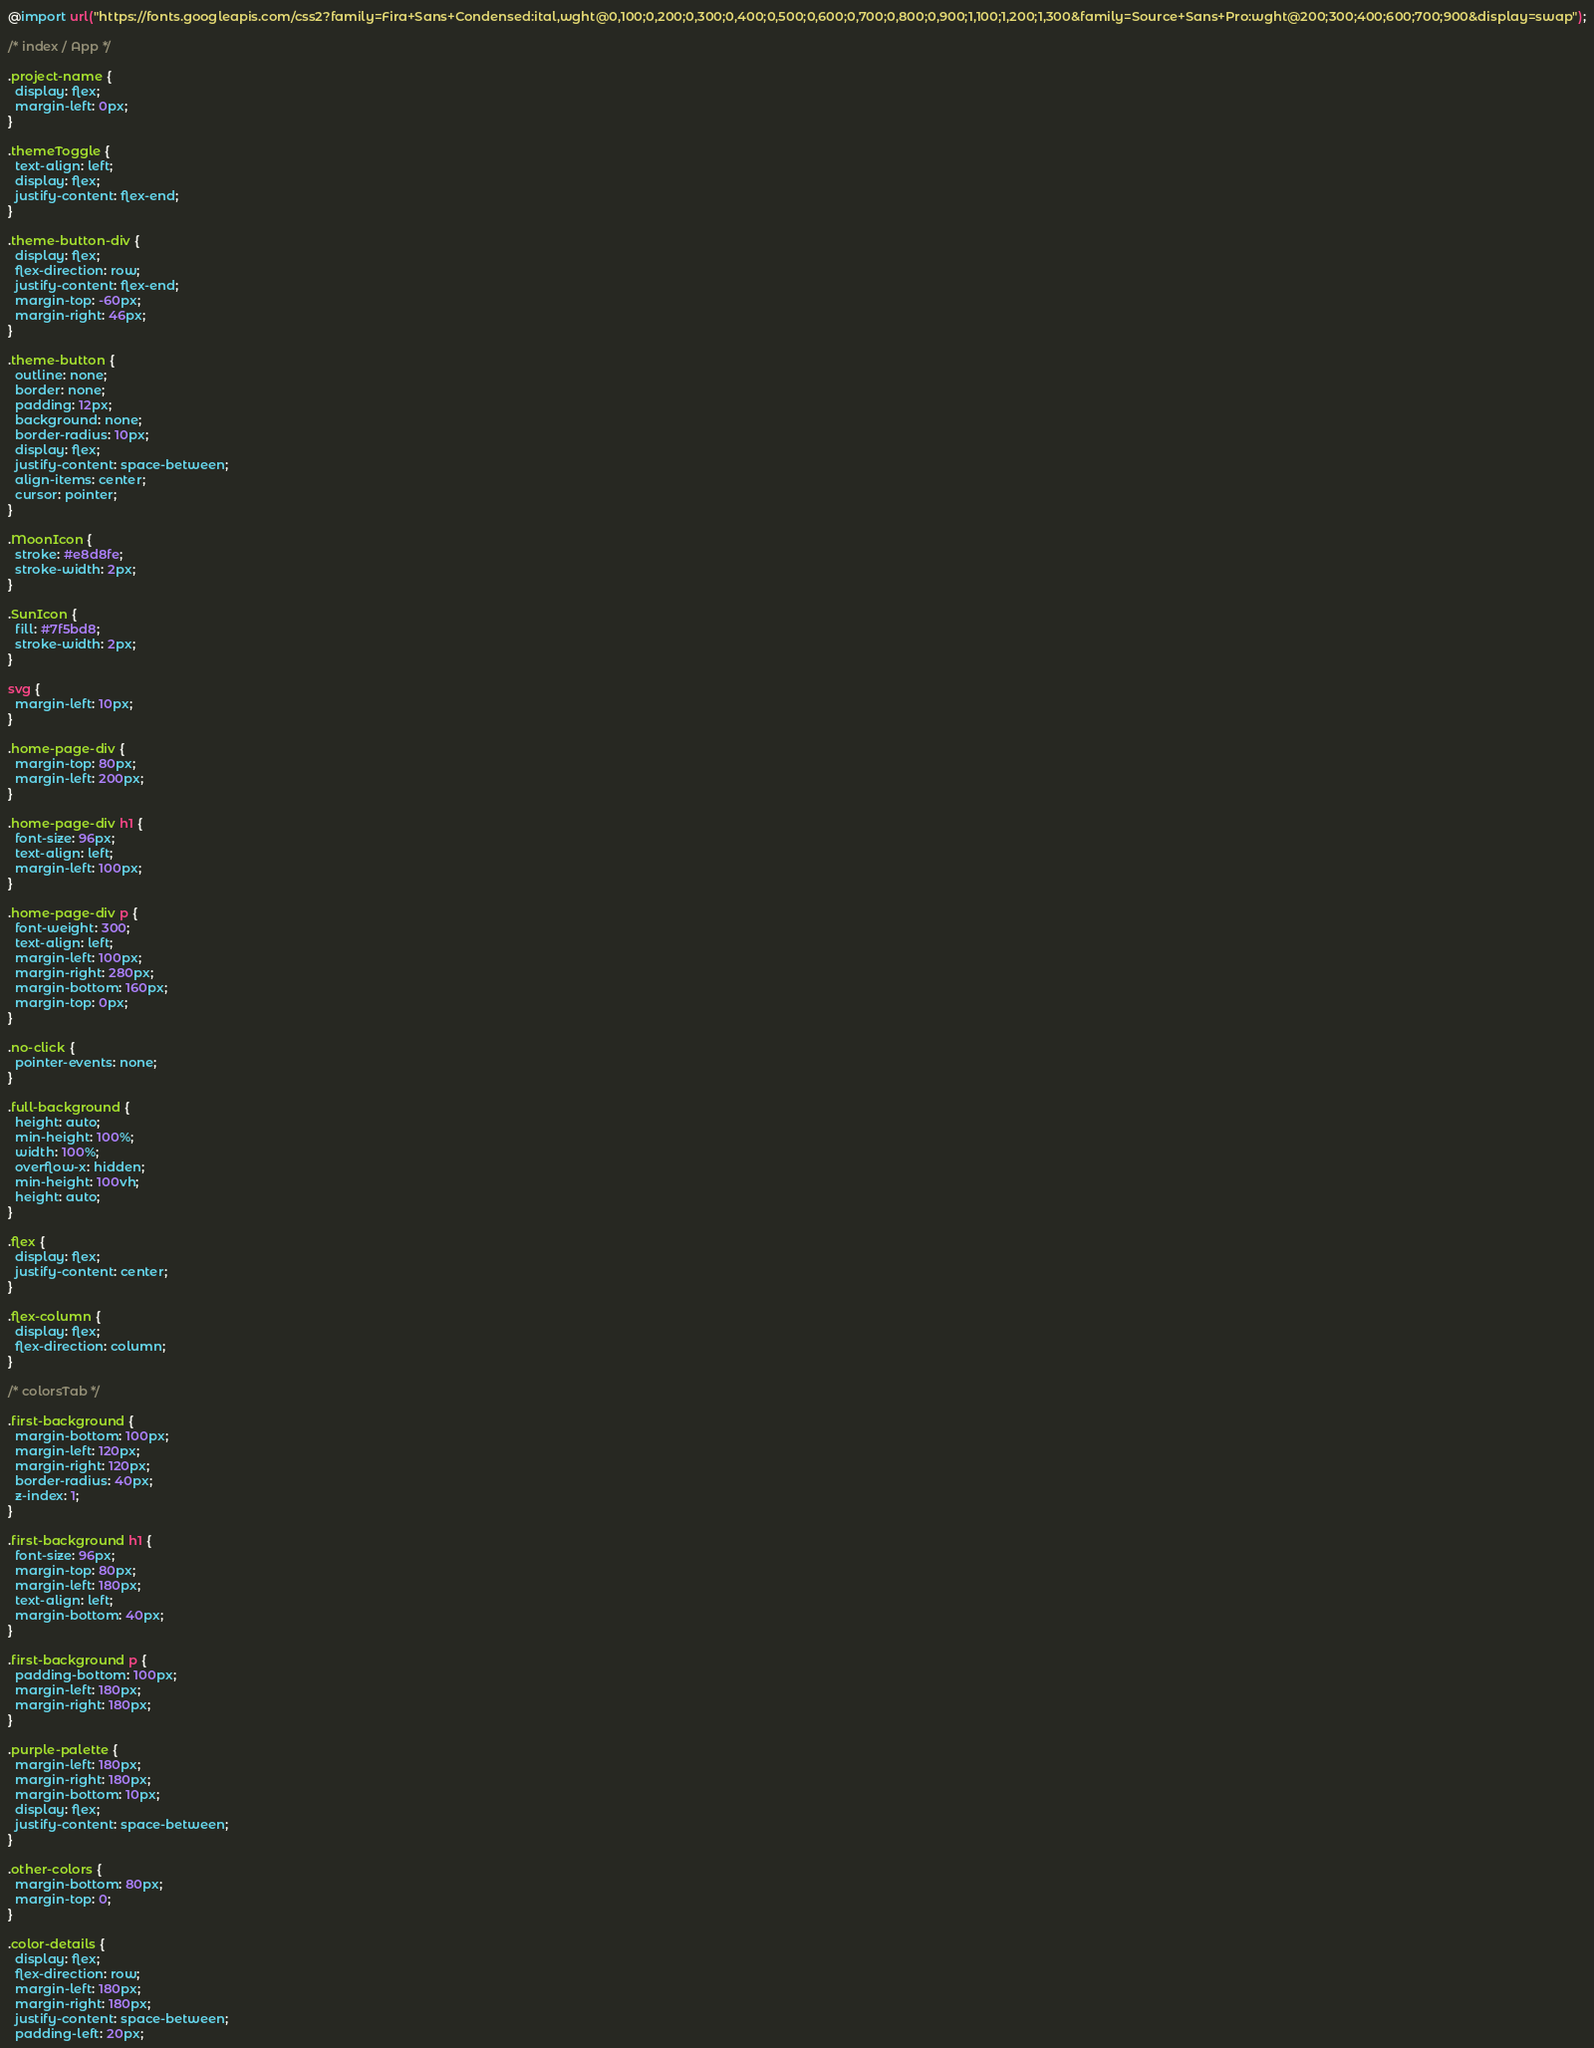<code> <loc_0><loc_0><loc_500><loc_500><_CSS_>@import url("https://fonts.googleapis.com/css2?family=Fira+Sans+Condensed:ital,wght@0,100;0,200;0,300;0,400;0,500;0,600;0,700;0,800;0,900;1,100;1,200;1,300&family=Source+Sans+Pro:wght@200;300;400;600;700;900&display=swap");

/* index / App */

.project-name {
  display: flex;
  margin-left: 0px;
}

.themeToggle {
  text-align: left;
  display: flex;
  justify-content: flex-end;
}

.theme-button-div {
  display: flex;
  flex-direction: row;
  justify-content: flex-end;
  margin-top: -60px;
  margin-right: 46px;
}

.theme-button {
  outline: none;
  border: none;
  padding: 12px;
  background: none;
  border-radius: 10px;
  display: flex;
  justify-content: space-between;
  align-items: center;
  cursor: pointer;
}

.MoonIcon {
  stroke: #e8d8fe;
  stroke-width: 2px;
}

.SunIcon {
  fill: #7f5bd8;
  stroke-width: 2px;
}

svg {
  margin-left: 10px;
}

.home-page-div {
  margin-top: 80px;
  margin-left: 200px;
}

.home-page-div h1 {
  font-size: 96px;
  text-align: left;
  margin-left: 100px;
}

.home-page-div p {
  font-weight: 300;
  text-align: left;
  margin-left: 100px;
  margin-right: 280px;
  margin-bottom: 160px;
  margin-top: 0px;
}

.no-click {
  pointer-events: none;
}

.full-background {
  height: auto;
  min-height: 100%;
  width: 100%;
  overflow-x: hidden;
  min-height: 100vh;
  height: auto;
}

.flex {
  display: flex;
  justify-content: center;
}

.flex-column {
  display: flex;
  flex-direction: column;
}

/* colorsTab */

.first-background {
  margin-bottom: 100px;
  margin-left: 120px;
  margin-right: 120px;
  border-radius: 40px;
  z-index: 1;
}

.first-background h1 {
  font-size: 96px;
  margin-top: 80px;
  margin-left: 180px;
  text-align: left;
  margin-bottom: 40px;
}

.first-background p {
  padding-bottom: 100px;
  margin-left: 180px;
  margin-right: 180px;
}

.purple-palette {
  margin-left: 180px;
  margin-right: 180px;
  margin-bottom: 10px;
  display: flex;
  justify-content: space-between;
}

.other-colors {
  margin-bottom: 80px;
  margin-top: 0;
}

.color-details {
  display: flex;
  flex-direction: row;
  margin-left: 180px;
  margin-right: 180px;
  justify-content: space-between;
  padding-left: 20px;</code> 